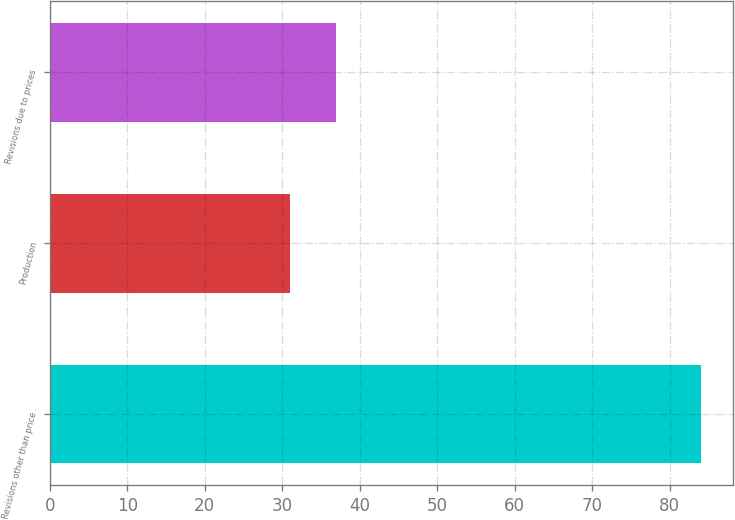Convert chart to OTSL. <chart><loc_0><loc_0><loc_500><loc_500><bar_chart><fcel>Revisions other than price<fcel>Production<fcel>Revisions due to prices<nl><fcel>84<fcel>31<fcel>37<nl></chart> 